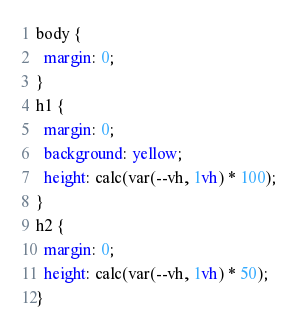<code> <loc_0><loc_0><loc_500><loc_500><_CSS_>body {
  margin: 0;
}
h1 {
  margin: 0;
  background: yellow;
  height: calc(var(--vh, 1vh) * 100);
}
h2 {
  margin: 0;
  height: calc(var(--vh, 1vh) * 50);
}
</code> 